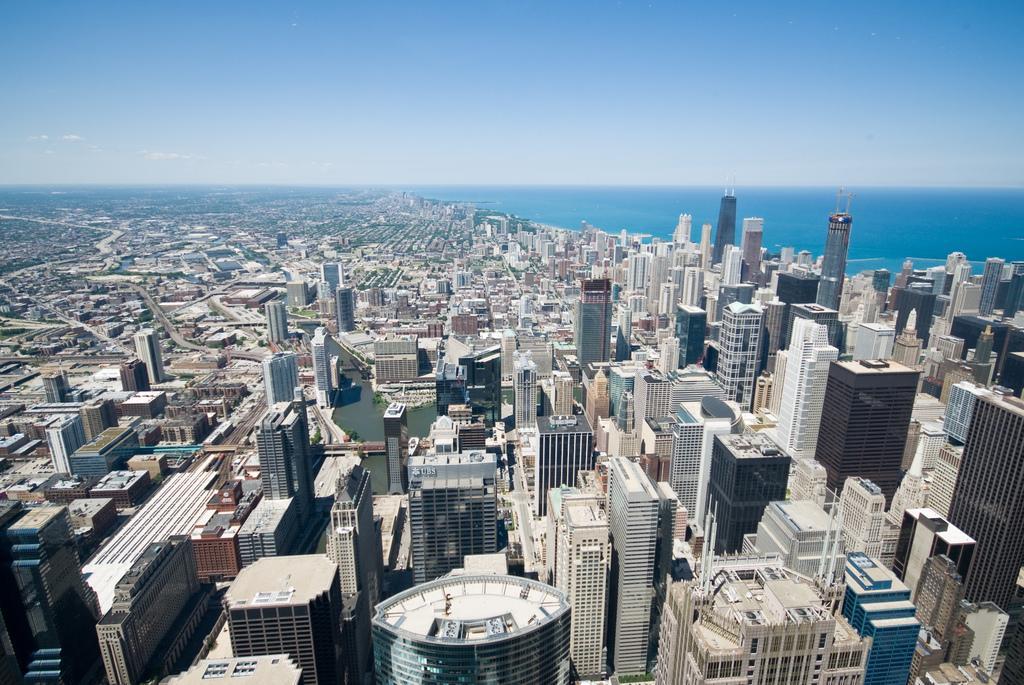Could you give a brief overview of what you see in this image? This is an aerial view in this image there are buildings, towers, sea and the sky. 